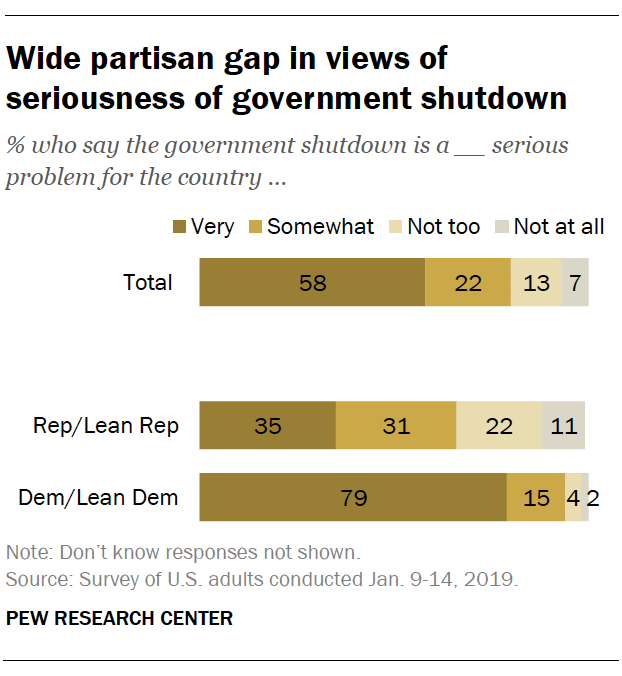Identify some key points in this picture. The average of all the bars in the Total category is 25. The color of the smallest bar is gray. 